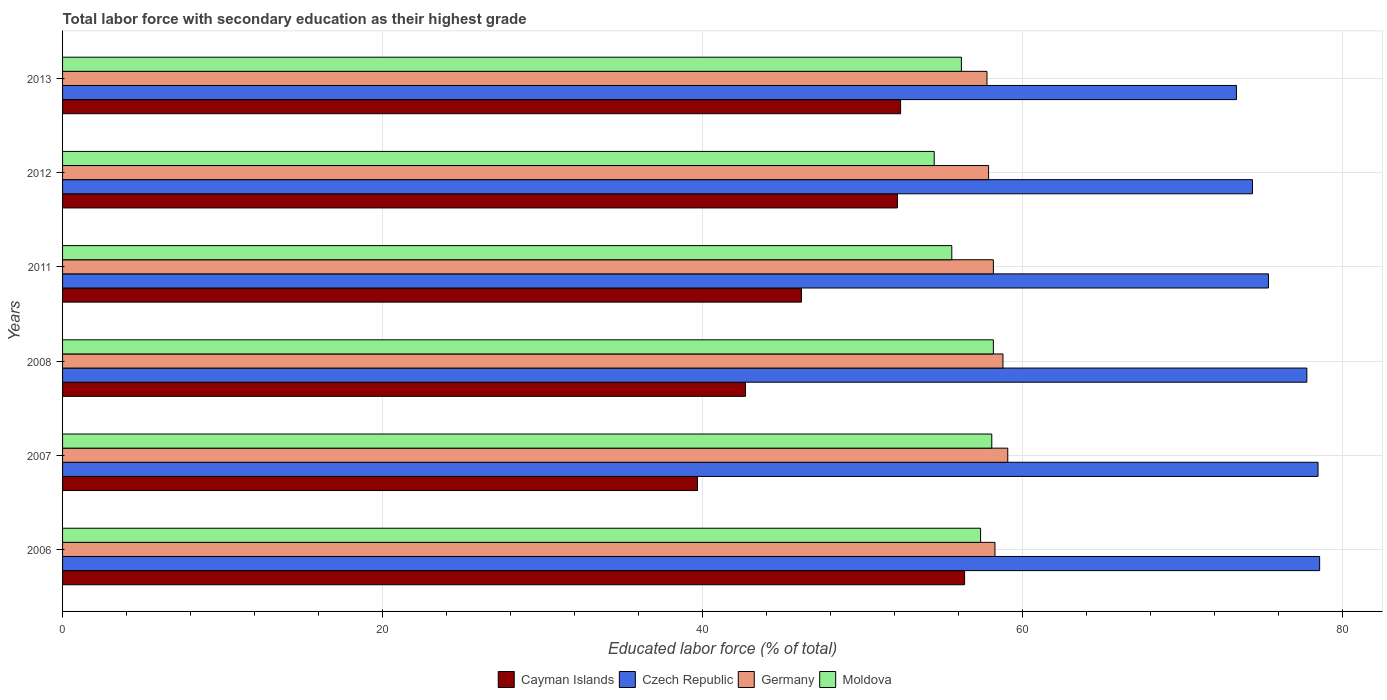How many groups of bars are there?
Offer a very short reply. 6. Are the number of bars per tick equal to the number of legend labels?
Offer a terse response. Yes. Are the number of bars on each tick of the Y-axis equal?
Offer a terse response. Yes. How many bars are there on the 5th tick from the top?
Your answer should be compact. 4. What is the label of the 5th group of bars from the top?
Ensure brevity in your answer.  2007. What is the percentage of total labor force with primary education in Cayman Islands in 2007?
Offer a terse response. 39.7. Across all years, what is the maximum percentage of total labor force with primary education in Czech Republic?
Ensure brevity in your answer.  78.6. Across all years, what is the minimum percentage of total labor force with primary education in Moldova?
Keep it short and to the point. 54.5. In which year was the percentage of total labor force with primary education in Moldova maximum?
Give a very brief answer. 2008. What is the total percentage of total labor force with primary education in Czech Republic in the graph?
Your answer should be very brief. 458.1. What is the difference between the percentage of total labor force with primary education in Germany in 2006 and that in 2013?
Provide a short and direct response. 0.5. What is the average percentage of total labor force with primary education in Czech Republic per year?
Provide a succinct answer. 76.35. In the year 2012, what is the difference between the percentage of total labor force with primary education in Czech Republic and percentage of total labor force with primary education in Moldova?
Offer a very short reply. 19.9. What is the ratio of the percentage of total labor force with primary education in Cayman Islands in 2006 to that in 2013?
Provide a succinct answer. 1.08. What is the difference between the highest and the second highest percentage of total labor force with primary education in Moldova?
Ensure brevity in your answer.  0.1. What is the difference between the highest and the lowest percentage of total labor force with primary education in Germany?
Give a very brief answer. 1.3. Is the sum of the percentage of total labor force with primary education in Germany in 2007 and 2012 greater than the maximum percentage of total labor force with primary education in Cayman Islands across all years?
Ensure brevity in your answer.  Yes. What does the 3rd bar from the top in 2006 represents?
Your answer should be very brief. Czech Republic. What does the 4th bar from the bottom in 2008 represents?
Make the answer very short. Moldova. Is it the case that in every year, the sum of the percentage of total labor force with primary education in Cayman Islands and percentage of total labor force with primary education in Czech Republic is greater than the percentage of total labor force with primary education in Moldova?
Ensure brevity in your answer.  Yes. How many bars are there?
Keep it short and to the point. 24. Are all the bars in the graph horizontal?
Offer a terse response. Yes. What is the difference between two consecutive major ticks on the X-axis?
Offer a terse response. 20. Are the values on the major ticks of X-axis written in scientific E-notation?
Your answer should be very brief. No. Does the graph contain any zero values?
Ensure brevity in your answer.  No. Where does the legend appear in the graph?
Offer a very short reply. Bottom center. How are the legend labels stacked?
Offer a terse response. Horizontal. What is the title of the graph?
Provide a succinct answer. Total labor force with secondary education as their highest grade. What is the label or title of the X-axis?
Your answer should be very brief. Educated labor force (% of total). What is the Educated labor force (% of total) in Cayman Islands in 2006?
Provide a succinct answer. 56.4. What is the Educated labor force (% of total) of Czech Republic in 2006?
Make the answer very short. 78.6. What is the Educated labor force (% of total) of Germany in 2006?
Offer a terse response. 58.3. What is the Educated labor force (% of total) in Moldova in 2006?
Your answer should be compact. 57.4. What is the Educated labor force (% of total) in Cayman Islands in 2007?
Make the answer very short. 39.7. What is the Educated labor force (% of total) in Czech Republic in 2007?
Provide a short and direct response. 78.5. What is the Educated labor force (% of total) in Germany in 2007?
Make the answer very short. 59.1. What is the Educated labor force (% of total) in Moldova in 2007?
Offer a terse response. 58.1. What is the Educated labor force (% of total) in Cayman Islands in 2008?
Offer a very short reply. 42.7. What is the Educated labor force (% of total) of Czech Republic in 2008?
Make the answer very short. 77.8. What is the Educated labor force (% of total) of Germany in 2008?
Give a very brief answer. 58.8. What is the Educated labor force (% of total) of Moldova in 2008?
Give a very brief answer. 58.2. What is the Educated labor force (% of total) of Cayman Islands in 2011?
Provide a succinct answer. 46.2. What is the Educated labor force (% of total) of Czech Republic in 2011?
Provide a short and direct response. 75.4. What is the Educated labor force (% of total) of Germany in 2011?
Give a very brief answer. 58.2. What is the Educated labor force (% of total) in Moldova in 2011?
Provide a succinct answer. 55.6. What is the Educated labor force (% of total) of Cayman Islands in 2012?
Keep it short and to the point. 52.2. What is the Educated labor force (% of total) of Czech Republic in 2012?
Your answer should be very brief. 74.4. What is the Educated labor force (% of total) in Germany in 2012?
Give a very brief answer. 57.9. What is the Educated labor force (% of total) of Moldova in 2012?
Offer a terse response. 54.5. What is the Educated labor force (% of total) of Cayman Islands in 2013?
Keep it short and to the point. 52.4. What is the Educated labor force (% of total) in Czech Republic in 2013?
Offer a very short reply. 73.4. What is the Educated labor force (% of total) in Germany in 2013?
Your answer should be compact. 57.8. What is the Educated labor force (% of total) in Moldova in 2013?
Make the answer very short. 56.2. Across all years, what is the maximum Educated labor force (% of total) of Cayman Islands?
Your response must be concise. 56.4. Across all years, what is the maximum Educated labor force (% of total) of Czech Republic?
Offer a terse response. 78.6. Across all years, what is the maximum Educated labor force (% of total) in Germany?
Your response must be concise. 59.1. Across all years, what is the maximum Educated labor force (% of total) of Moldova?
Ensure brevity in your answer.  58.2. Across all years, what is the minimum Educated labor force (% of total) in Cayman Islands?
Make the answer very short. 39.7. Across all years, what is the minimum Educated labor force (% of total) in Czech Republic?
Keep it short and to the point. 73.4. Across all years, what is the minimum Educated labor force (% of total) in Germany?
Your answer should be very brief. 57.8. Across all years, what is the minimum Educated labor force (% of total) in Moldova?
Your answer should be compact. 54.5. What is the total Educated labor force (% of total) in Cayman Islands in the graph?
Provide a short and direct response. 289.6. What is the total Educated labor force (% of total) in Czech Republic in the graph?
Your response must be concise. 458.1. What is the total Educated labor force (% of total) of Germany in the graph?
Offer a terse response. 350.1. What is the total Educated labor force (% of total) of Moldova in the graph?
Your answer should be very brief. 340. What is the difference between the Educated labor force (% of total) in Czech Republic in 2006 and that in 2007?
Your response must be concise. 0.1. What is the difference between the Educated labor force (% of total) of Germany in 2006 and that in 2007?
Provide a short and direct response. -0.8. What is the difference between the Educated labor force (% of total) of Czech Republic in 2006 and that in 2008?
Provide a short and direct response. 0.8. What is the difference between the Educated labor force (% of total) of Germany in 2006 and that in 2008?
Your answer should be very brief. -0.5. What is the difference between the Educated labor force (% of total) of Moldova in 2006 and that in 2011?
Provide a succinct answer. 1.8. What is the difference between the Educated labor force (% of total) in Czech Republic in 2006 and that in 2012?
Provide a succinct answer. 4.2. What is the difference between the Educated labor force (% of total) in Germany in 2006 and that in 2012?
Your response must be concise. 0.4. What is the difference between the Educated labor force (% of total) in Czech Republic in 2007 and that in 2008?
Your answer should be very brief. 0.7. What is the difference between the Educated labor force (% of total) in Moldova in 2007 and that in 2008?
Your answer should be compact. -0.1. What is the difference between the Educated labor force (% of total) of Cayman Islands in 2007 and that in 2011?
Provide a short and direct response. -6.5. What is the difference between the Educated labor force (% of total) of Moldova in 2007 and that in 2011?
Your answer should be compact. 2.5. What is the difference between the Educated labor force (% of total) in Czech Republic in 2007 and that in 2012?
Give a very brief answer. 4.1. What is the difference between the Educated labor force (% of total) of Germany in 2007 and that in 2013?
Your response must be concise. 1.3. What is the difference between the Educated labor force (% of total) of Cayman Islands in 2008 and that in 2011?
Provide a succinct answer. -3.5. What is the difference between the Educated labor force (% of total) in Germany in 2008 and that in 2011?
Your response must be concise. 0.6. What is the difference between the Educated labor force (% of total) of Cayman Islands in 2008 and that in 2012?
Offer a very short reply. -9.5. What is the difference between the Educated labor force (% of total) in Germany in 2008 and that in 2012?
Keep it short and to the point. 0.9. What is the difference between the Educated labor force (% of total) in Moldova in 2008 and that in 2012?
Your response must be concise. 3.7. What is the difference between the Educated labor force (% of total) in Cayman Islands in 2008 and that in 2013?
Provide a short and direct response. -9.7. What is the difference between the Educated labor force (% of total) in Germany in 2008 and that in 2013?
Keep it short and to the point. 1. What is the difference between the Educated labor force (% of total) in Moldova in 2008 and that in 2013?
Offer a very short reply. 2. What is the difference between the Educated labor force (% of total) in Germany in 2011 and that in 2012?
Ensure brevity in your answer.  0.3. What is the difference between the Educated labor force (% of total) of Moldova in 2011 and that in 2012?
Offer a very short reply. 1.1. What is the difference between the Educated labor force (% of total) of Cayman Islands in 2011 and that in 2013?
Make the answer very short. -6.2. What is the difference between the Educated labor force (% of total) in Czech Republic in 2011 and that in 2013?
Provide a short and direct response. 2. What is the difference between the Educated labor force (% of total) of Moldova in 2011 and that in 2013?
Provide a short and direct response. -0.6. What is the difference between the Educated labor force (% of total) in Cayman Islands in 2012 and that in 2013?
Provide a succinct answer. -0.2. What is the difference between the Educated labor force (% of total) in Czech Republic in 2012 and that in 2013?
Keep it short and to the point. 1. What is the difference between the Educated labor force (% of total) in Germany in 2012 and that in 2013?
Your answer should be very brief. 0.1. What is the difference between the Educated labor force (% of total) of Moldova in 2012 and that in 2013?
Offer a very short reply. -1.7. What is the difference between the Educated labor force (% of total) in Cayman Islands in 2006 and the Educated labor force (% of total) in Czech Republic in 2007?
Your answer should be very brief. -22.1. What is the difference between the Educated labor force (% of total) in Cayman Islands in 2006 and the Educated labor force (% of total) in Moldova in 2007?
Offer a very short reply. -1.7. What is the difference between the Educated labor force (% of total) in Czech Republic in 2006 and the Educated labor force (% of total) in Germany in 2007?
Give a very brief answer. 19.5. What is the difference between the Educated labor force (% of total) of Czech Republic in 2006 and the Educated labor force (% of total) of Moldova in 2007?
Provide a short and direct response. 20.5. What is the difference between the Educated labor force (% of total) of Germany in 2006 and the Educated labor force (% of total) of Moldova in 2007?
Give a very brief answer. 0.2. What is the difference between the Educated labor force (% of total) of Cayman Islands in 2006 and the Educated labor force (% of total) of Czech Republic in 2008?
Make the answer very short. -21.4. What is the difference between the Educated labor force (% of total) of Cayman Islands in 2006 and the Educated labor force (% of total) of Germany in 2008?
Offer a very short reply. -2.4. What is the difference between the Educated labor force (% of total) in Czech Republic in 2006 and the Educated labor force (% of total) in Germany in 2008?
Your answer should be compact. 19.8. What is the difference between the Educated labor force (% of total) in Czech Republic in 2006 and the Educated labor force (% of total) in Moldova in 2008?
Your response must be concise. 20.4. What is the difference between the Educated labor force (% of total) of Germany in 2006 and the Educated labor force (% of total) of Moldova in 2008?
Make the answer very short. 0.1. What is the difference between the Educated labor force (% of total) in Cayman Islands in 2006 and the Educated labor force (% of total) in Germany in 2011?
Your response must be concise. -1.8. What is the difference between the Educated labor force (% of total) of Czech Republic in 2006 and the Educated labor force (% of total) of Germany in 2011?
Ensure brevity in your answer.  20.4. What is the difference between the Educated labor force (% of total) of Czech Republic in 2006 and the Educated labor force (% of total) of Moldova in 2011?
Make the answer very short. 23. What is the difference between the Educated labor force (% of total) in Germany in 2006 and the Educated labor force (% of total) in Moldova in 2011?
Your response must be concise. 2.7. What is the difference between the Educated labor force (% of total) of Cayman Islands in 2006 and the Educated labor force (% of total) of Moldova in 2012?
Provide a succinct answer. 1.9. What is the difference between the Educated labor force (% of total) of Czech Republic in 2006 and the Educated labor force (% of total) of Germany in 2012?
Ensure brevity in your answer.  20.7. What is the difference between the Educated labor force (% of total) of Czech Republic in 2006 and the Educated labor force (% of total) of Moldova in 2012?
Provide a short and direct response. 24.1. What is the difference between the Educated labor force (% of total) in Germany in 2006 and the Educated labor force (% of total) in Moldova in 2012?
Keep it short and to the point. 3.8. What is the difference between the Educated labor force (% of total) of Cayman Islands in 2006 and the Educated labor force (% of total) of Czech Republic in 2013?
Offer a very short reply. -17. What is the difference between the Educated labor force (% of total) of Cayman Islands in 2006 and the Educated labor force (% of total) of Moldova in 2013?
Offer a very short reply. 0.2. What is the difference between the Educated labor force (% of total) in Czech Republic in 2006 and the Educated labor force (% of total) in Germany in 2013?
Ensure brevity in your answer.  20.8. What is the difference between the Educated labor force (% of total) in Czech Republic in 2006 and the Educated labor force (% of total) in Moldova in 2013?
Your answer should be compact. 22.4. What is the difference between the Educated labor force (% of total) of Cayman Islands in 2007 and the Educated labor force (% of total) of Czech Republic in 2008?
Give a very brief answer. -38.1. What is the difference between the Educated labor force (% of total) of Cayman Islands in 2007 and the Educated labor force (% of total) of Germany in 2008?
Keep it short and to the point. -19.1. What is the difference between the Educated labor force (% of total) of Cayman Islands in 2007 and the Educated labor force (% of total) of Moldova in 2008?
Your response must be concise. -18.5. What is the difference between the Educated labor force (% of total) in Czech Republic in 2007 and the Educated labor force (% of total) in Moldova in 2008?
Give a very brief answer. 20.3. What is the difference between the Educated labor force (% of total) in Germany in 2007 and the Educated labor force (% of total) in Moldova in 2008?
Your answer should be compact. 0.9. What is the difference between the Educated labor force (% of total) in Cayman Islands in 2007 and the Educated labor force (% of total) in Czech Republic in 2011?
Offer a very short reply. -35.7. What is the difference between the Educated labor force (% of total) of Cayman Islands in 2007 and the Educated labor force (% of total) of Germany in 2011?
Make the answer very short. -18.5. What is the difference between the Educated labor force (% of total) of Cayman Islands in 2007 and the Educated labor force (% of total) of Moldova in 2011?
Your response must be concise. -15.9. What is the difference between the Educated labor force (% of total) of Czech Republic in 2007 and the Educated labor force (% of total) of Germany in 2011?
Your answer should be very brief. 20.3. What is the difference between the Educated labor force (% of total) of Czech Republic in 2007 and the Educated labor force (% of total) of Moldova in 2011?
Offer a terse response. 22.9. What is the difference between the Educated labor force (% of total) in Germany in 2007 and the Educated labor force (% of total) in Moldova in 2011?
Make the answer very short. 3.5. What is the difference between the Educated labor force (% of total) of Cayman Islands in 2007 and the Educated labor force (% of total) of Czech Republic in 2012?
Your answer should be very brief. -34.7. What is the difference between the Educated labor force (% of total) in Cayman Islands in 2007 and the Educated labor force (% of total) in Germany in 2012?
Provide a succinct answer. -18.2. What is the difference between the Educated labor force (% of total) in Cayman Islands in 2007 and the Educated labor force (% of total) in Moldova in 2012?
Give a very brief answer. -14.8. What is the difference between the Educated labor force (% of total) in Czech Republic in 2007 and the Educated labor force (% of total) in Germany in 2012?
Offer a terse response. 20.6. What is the difference between the Educated labor force (% of total) in Czech Republic in 2007 and the Educated labor force (% of total) in Moldova in 2012?
Your response must be concise. 24. What is the difference between the Educated labor force (% of total) of Germany in 2007 and the Educated labor force (% of total) of Moldova in 2012?
Offer a terse response. 4.6. What is the difference between the Educated labor force (% of total) of Cayman Islands in 2007 and the Educated labor force (% of total) of Czech Republic in 2013?
Ensure brevity in your answer.  -33.7. What is the difference between the Educated labor force (% of total) in Cayman Islands in 2007 and the Educated labor force (% of total) in Germany in 2013?
Offer a very short reply. -18.1. What is the difference between the Educated labor force (% of total) in Cayman Islands in 2007 and the Educated labor force (% of total) in Moldova in 2013?
Offer a very short reply. -16.5. What is the difference between the Educated labor force (% of total) in Czech Republic in 2007 and the Educated labor force (% of total) in Germany in 2013?
Your response must be concise. 20.7. What is the difference between the Educated labor force (% of total) of Czech Republic in 2007 and the Educated labor force (% of total) of Moldova in 2013?
Provide a succinct answer. 22.3. What is the difference between the Educated labor force (% of total) of Germany in 2007 and the Educated labor force (% of total) of Moldova in 2013?
Provide a succinct answer. 2.9. What is the difference between the Educated labor force (% of total) of Cayman Islands in 2008 and the Educated labor force (% of total) of Czech Republic in 2011?
Make the answer very short. -32.7. What is the difference between the Educated labor force (% of total) of Cayman Islands in 2008 and the Educated labor force (% of total) of Germany in 2011?
Your answer should be very brief. -15.5. What is the difference between the Educated labor force (% of total) in Cayman Islands in 2008 and the Educated labor force (% of total) in Moldova in 2011?
Your answer should be very brief. -12.9. What is the difference between the Educated labor force (% of total) of Czech Republic in 2008 and the Educated labor force (% of total) of Germany in 2011?
Ensure brevity in your answer.  19.6. What is the difference between the Educated labor force (% of total) in Cayman Islands in 2008 and the Educated labor force (% of total) in Czech Republic in 2012?
Your answer should be compact. -31.7. What is the difference between the Educated labor force (% of total) of Cayman Islands in 2008 and the Educated labor force (% of total) of Germany in 2012?
Offer a very short reply. -15.2. What is the difference between the Educated labor force (% of total) of Czech Republic in 2008 and the Educated labor force (% of total) of Moldova in 2012?
Keep it short and to the point. 23.3. What is the difference between the Educated labor force (% of total) of Cayman Islands in 2008 and the Educated labor force (% of total) of Czech Republic in 2013?
Make the answer very short. -30.7. What is the difference between the Educated labor force (% of total) of Cayman Islands in 2008 and the Educated labor force (% of total) of Germany in 2013?
Provide a short and direct response. -15.1. What is the difference between the Educated labor force (% of total) of Cayman Islands in 2008 and the Educated labor force (% of total) of Moldova in 2013?
Your answer should be very brief. -13.5. What is the difference between the Educated labor force (% of total) of Czech Republic in 2008 and the Educated labor force (% of total) of Germany in 2013?
Ensure brevity in your answer.  20. What is the difference between the Educated labor force (% of total) in Czech Republic in 2008 and the Educated labor force (% of total) in Moldova in 2013?
Ensure brevity in your answer.  21.6. What is the difference between the Educated labor force (% of total) in Cayman Islands in 2011 and the Educated labor force (% of total) in Czech Republic in 2012?
Your response must be concise. -28.2. What is the difference between the Educated labor force (% of total) in Czech Republic in 2011 and the Educated labor force (% of total) in Moldova in 2012?
Keep it short and to the point. 20.9. What is the difference between the Educated labor force (% of total) of Germany in 2011 and the Educated labor force (% of total) of Moldova in 2012?
Your answer should be very brief. 3.7. What is the difference between the Educated labor force (% of total) of Cayman Islands in 2011 and the Educated labor force (% of total) of Czech Republic in 2013?
Provide a succinct answer. -27.2. What is the difference between the Educated labor force (% of total) in Czech Republic in 2011 and the Educated labor force (% of total) in Moldova in 2013?
Ensure brevity in your answer.  19.2. What is the difference between the Educated labor force (% of total) of Germany in 2011 and the Educated labor force (% of total) of Moldova in 2013?
Ensure brevity in your answer.  2. What is the difference between the Educated labor force (% of total) in Cayman Islands in 2012 and the Educated labor force (% of total) in Czech Republic in 2013?
Make the answer very short. -21.2. What is the difference between the Educated labor force (% of total) of Cayman Islands in 2012 and the Educated labor force (% of total) of Germany in 2013?
Provide a succinct answer. -5.6. What is the difference between the Educated labor force (% of total) of Czech Republic in 2012 and the Educated labor force (% of total) of Germany in 2013?
Your response must be concise. 16.6. What is the average Educated labor force (% of total) of Cayman Islands per year?
Offer a very short reply. 48.27. What is the average Educated labor force (% of total) of Czech Republic per year?
Offer a very short reply. 76.35. What is the average Educated labor force (% of total) of Germany per year?
Your answer should be very brief. 58.35. What is the average Educated labor force (% of total) of Moldova per year?
Make the answer very short. 56.67. In the year 2006, what is the difference between the Educated labor force (% of total) in Cayman Islands and Educated labor force (% of total) in Czech Republic?
Your response must be concise. -22.2. In the year 2006, what is the difference between the Educated labor force (% of total) of Cayman Islands and Educated labor force (% of total) of Germany?
Your answer should be very brief. -1.9. In the year 2006, what is the difference between the Educated labor force (% of total) in Cayman Islands and Educated labor force (% of total) in Moldova?
Your response must be concise. -1. In the year 2006, what is the difference between the Educated labor force (% of total) of Czech Republic and Educated labor force (% of total) of Germany?
Ensure brevity in your answer.  20.3. In the year 2006, what is the difference between the Educated labor force (% of total) in Czech Republic and Educated labor force (% of total) in Moldova?
Offer a very short reply. 21.2. In the year 2006, what is the difference between the Educated labor force (% of total) in Germany and Educated labor force (% of total) in Moldova?
Provide a short and direct response. 0.9. In the year 2007, what is the difference between the Educated labor force (% of total) of Cayman Islands and Educated labor force (% of total) of Czech Republic?
Provide a short and direct response. -38.8. In the year 2007, what is the difference between the Educated labor force (% of total) in Cayman Islands and Educated labor force (% of total) in Germany?
Provide a succinct answer. -19.4. In the year 2007, what is the difference between the Educated labor force (% of total) in Cayman Islands and Educated labor force (% of total) in Moldova?
Keep it short and to the point. -18.4. In the year 2007, what is the difference between the Educated labor force (% of total) of Czech Republic and Educated labor force (% of total) of Moldova?
Give a very brief answer. 20.4. In the year 2008, what is the difference between the Educated labor force (% of total) of Cayman Islands and Educated labor force (% of total) of Czech Republic?
Ensure brevity in your answer.  -35.1. In the year 2008, what is the difference between the Educated labor force (% of total) of Cayman Islands and Educated labor force (% of total) of Germany?
Provide a short and direct response. -16.1. In the year 2008, what is the difference between the Educated labor force (% of total) in Cayman Islands and Educated labor force (% of total) in Moldova?
Offer a very short reply. -15.5. In the year 2008, what is the difference between the Educated labor force (% of total) of Czech Republic and Educated labor force (% of total) of Germany?
Provide a short and direct response. 19. In the year 2008, what is the difference between the Educated labor force (% of total) in Czech Republic and Educated labor force (% of total) in Moldova?
Offer a very short reply. 19.6. In the year 2008, what is the difference between the Educated labor force (% of total) of Germany and Educated labor force (% of total) of Moldova?
Offer a very short reply. 0.6. In the year 2011, what is the difference between the Educated labor force (% of total) of Cayman Islands and Educated labor force (% of total) of Czech Republic?
Offer a terse response. -29.2. In the year 2011, what is the difference between the Educated labor force (% of total) of Cayman Islands and Educated labor force (% of total) of Germany?
Provide a succinct answer. -12. In the year 2011, what is the difference between the Educated labor force (% of total) of Czech Republic and Educated labor force (% of total) of Germany?
Your answer should be compact. 17.2. In the year 2011, what is the difference between the Educated labor force (% of total) of Czech Republic and Educated labor force (% of total) of Moldova?
Your answer should be compact. 19.8. In the year 2012, what is the difference between the Educated labor force (% of total) in Cayman Islands and Educated labor force (% of total) in Czech Republic?
Provide a short and direct response. -22.2. In the year 2012, what is the difference between the Educated labor force (% of total) of Czech Republic and Educated labor force (% of total) of Germany?
Keep it short and to the point. 16.5. In the year 2012, what is the difference between the Educated labor force (% of total) of Czech Republic and Educated labor force (% of total) of Moldova?
Give a very brief answer. 19.9. In the year 2012, what is the difference between the Educated labor force (% of total) in Germany and Educated labor force (% of total) in Moldova?
Make the answer very short. 3.4. In the year 2013, what is the difference between the Educated labor force (% of total) in Cayman Islands and Educated labor force (% of total) in Germany?
Your response must be concise. -5.4. In the year 2013, what is the difference between the Educated labor force (% of total) in Czech Republic and Educated labor force (% of total) in Moldova?
Make the answer very short. 17.2. What is the ratio of the Educated labor force (% of total) of Cayman Islands in 2006 to that in 2007?
Your answer should be compact. 1.42. What is the ratio of the Educated labor force (% of total) in Germany in 2006 to that in 2007?
Provide a short and direct response. 0.99. What is the ratio of the Educated labor force (% of total) of Cayman Islands in 2006 to that in 2008?
Offer a very short reply. 1.32. What is the ratio of the Educated labor force (% of total) in Czech Republic in 2006 to that in 2008?
Make the answer very short. 1.01. What is the ratio of the Educated labor force (% of total) in Moldova in 2006 to that in 2008?
Offer a very short reply. 0.99. What is the ratio of the Educated labor force (% of total) in Cayman Islands in 2006 to that in 2011?
Your answer should be compact. 1.22. What is the ratio of the Educated labor force (% of total) of Czech Republic in 2006 to that in 2011?
Provide a short and direct response. 1.04. What is the ratio of the Educated labor force (% of total) of Moldova in 2006 to that in 2011?
Offer a terse response. 1.03. What is the ratio of the Educated labor force (% of total) of Cayman Islands in 2006 to that in 2012?
Offer a very short reply. 1.08. What is the ratio of the Educated labor force (% of total) in Czech Republic in 2006 to that in 2012?
Your answer should be compact. 1.06. What is the ratio of the Educated labor force (% of total) of Germany in 2006 to that in 2012?
Your answer should be compact. 1.01. What is the ratio of the Educated labor force (% of total) of Moldova in 2006 to that in 2012?
Your answer should be compact. 1.05. What is the ratio of the Educated labor force (% of total) of Cayman Islands in 2006 to that in 2013?
Your answer should be very brief. 1.08. What is the ratio of the Educated labor force (% of total) in Czech Republic in 2006 to that in 2013?
Offer a terse response. 1.07. What is the ratio of the Educated labor force (% of total) of Germany in 2006 to that in 2013?
Offer a very short reply. 1.01. What is the ratio of the Educated labor force (% of total) in Moldova in 2006 to that in 2013?
Make the answer very short. 1.02. What is the ratio of the Educated labor force (% of total) of Cayman Islands in 2007 to that in 2008?
Offer a very short reply. 0.93. What is the ratio of the Educated labor force (% of total) in Moldova in 2007 to that in 2008?
Ensure brevity in your answer.  1. What is the ratio of the Educated labor force (% of total) in Cayman Islands in 2007 to that in 2011?
Keep it short and to the point. 0.86. What is the ratio of the Educated labor force (% of total) in Czech Republic in 2007 to that in 2011?
Make the answer very short. 1.04. What is the ratio of the Educated labor force (% of total) of Germany in 2007 to that in 2011?
Provide a short and direct response. 1.02. What is the ratio of the Educated labor force (% of total) in Moldova in 2007 to that in 2011?
Offer a very short reply. 1.04. What is the ratio of the Educated labor force (% of total) in Cayman Islands in 2007 to that in 2012?
Make the answer very short. 0.76. What is the ratio of the Educated labor force (% of total) of Czech Republic in 2007 to that in 2012?
Your answer should be compact. 1.06. What is the ratio of the Educated labor force (% of total) of Germany in 2007 to that in 2012?
Your answer should be compact. 1.02. What is the ratio of the Educated labor force (% of total) of Moldova in 2007 to that in 2012?
Your answer should be compact. 1.07. What is the ratio of the Educated labor force (% of total) of Cayman Islands in 2007 to that in 2013?
Ensure brevity in your answer.  0.76. What is the ratio of the Educated labor force (% of total) in Czech Republic in 2007 to that in 2013?
Offer a terse response. 1.07. What is the ratio of the Educated labor force (% of total) of Germany in 2007 to that in 2013?
Make the answer very short. 1.02. What is the ratio of the Educated labor force (% of total) of Moldova in 2007 to that in 2013?
Your answer should be very brief. 1.03. What is the ratio of the Educated labor force (% of total) in Cayman Islands in 2008 to that in 2011?
Provide a succinct answer. 0.92. What is the ratio of the Educated labor force (% of total) in Czech Republic in 2008 to that in 2011?
Your answer should be compact. 1.03. What is the ratio of the Educated labor force (% of total) of Germany in 2008 to that in 2011?
Provide a succinct answer. 1.01. What is the ratio of the Educated labor force (% of total) of Moldova in 2008 to that in 2011?
Your answer should be compact. 1.05. What is the ratio of the Educated labor force (% of total) in Cayman Islands in 2008 to that in 2012?
Keep it short and to the point. 0.82. What is the ratio of the Educated labor force (% of total) of Czech Republic in 2008 to that in 2012?
Give a very brief answer. 1.05. What is the ratio of the Educated labor force (% of total) in Germany in 2008 to that in 2012?
Make the answer very short. 1.02. What is the ratio of the Educated labor force (% of total) in Moldova in 2008 to that in 2012?
Your response must be concise. 1.07. What is the ratio of the Educated labor force (% of total) of Cayman Islands in 2008 to that in 2013?
Your response must be concise. 0.81. What is the ratio of the Educated labor force (% of total) of Czech Republic in 2008 to that in 2013?
Give a very brief answer. 1.06. What is the ratio of the Educated labor force (% of total) in Germany in 2008 to that in 2013?
Keep it short and to the point. 1.02. What is the ratio of the Educated labor force (% of total) of Moldova in 2008 to that in 2013?
Your answer should be compact. 1.04. What is the ratio of the Educated labor force (% of total) in Cayman Islands in 2011 to that in 2012?
Offer a terse response. 0.89. What is the ratio of the Educated labor force (% of total) in Czech Republic in 2011 to that in 2012?
Keep it short and to the point. 1.01. What is the ratio of the Educated labor force (% of total) in Moldova in 2011 to that in 2012?
Your answer should be compact. 1.02. What is the ratio of the Educated labor force (% of total) in Cayman Islands in 2011 to that in 2013?
Give a very brief answer. 0.88. What is the ratio of the Educated labor force (% of total) of Czech Republic in 2011 to that in 2013?
Provide a succinct answer. 1.03. What is the ratio of the Educated labor force (% of total) of Moldova in 2011 to that in 2013?
Your response must be concise. 0.99. What is the ratio of the Educated labor force (% of total) in Cayman Islands in 2012 to that in 2013?
Offer a terse response. 1. What is the ratio of the Educated labor force (% of total) of Czech Republic in 2012 to that in 2013?
Your response must be concise. 1.01. What is the ratio of the Educated labor force (% of total) of Moldova in 2012 to that in 2013?
Offer a terse response. 0.97. What is the difference between the highest and the second highest Educated labor force (% of total) of Cayman Islands?
Ensure brevity in your answer.  4. What is the difference between the highest and the second highest Educated labor force (% of total) in Moldova?
Your answer should be very brief. 0.1. What is the difference between the highest and the lowest Educated labor force (% of total) in Cayman Islands?
Keep it short and to the point. 16.7. What is the difference between the highest and the lowest Educated labor force (% of total) of Czech Republic?
Offer a terse response. 5.2. What is the difference between the highest and the lowest Educated labor force (% of total) in Germany?
Provide a succinct answer. 1.3. What is the difference between the highest and the lowest Educated labor force (% of total) of Moldova?
Your answer should be compact. 3.7. 